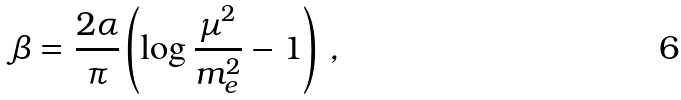Convert formula to latex. <formula><loc_0><loc_0><loc_500><loc_500>\beta = \frac { 2 \alpha } { \pi } \left ( \log \frac { \mu ^ { 2 } } { m _ { e } ^ { 2 } } - 1 \right ) \, ,</formula> 